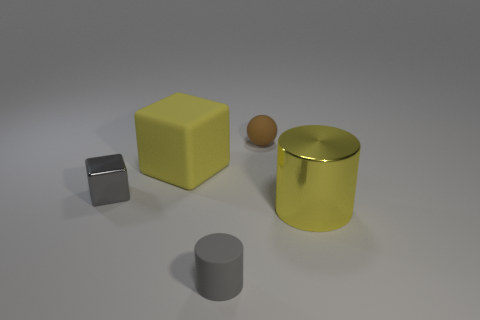How many other matte objects have the same shape as the small brown object?
Provide a succinct answer. 0. What material is the cylinder that is in front of the big object that is in front of the tiny shiny block?
Offer a very short reply. Rubber. How big is the yellow object behind the small gray cube?
Provide a succinct answer. Large. What number of yellow objects are either blocks or large matte things?
Offer a very short reply. 1. There is a large yellow thing that is the same shape as the gray matte object; what is it made of?
Offer a terse response. Metal. Is the number of small matte objects in front of the yellow metal cylinder the same as the number of small brown metallic cylinders?
Offer a very short reply. No. How big is the matte thing that is both on the left side of the tiny brown object and to the right of the matte cube?
Provide a short and direct response. Small. Is there anything else that has the same color as the tiny metal thing?
Provide a short and direct response. Yes. What is the size of the gray thing on the left side of the big yellow thing that is behind the gray shiny block?
Your answer should be very brief. Small. The object that is both in front of the tiny metallic cube and behind the gray rubber cylinder is what color?
Your answer should be very brief. Yellow. 